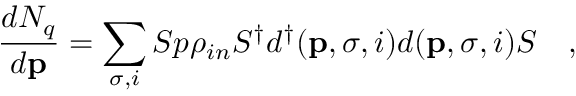Convert formula to latex. <formula><loc_0><loc_0><loc_500><loc_500>{ \frac { d N _ { q } } { d { p } } } = \sum _ { \sigma , i } S p \rho _ { i n } S ^ { \dag } d ^ { \dag } ( { p } , \sigma , i ) d ( { p } , \sigma , i ) S ,</formula> 